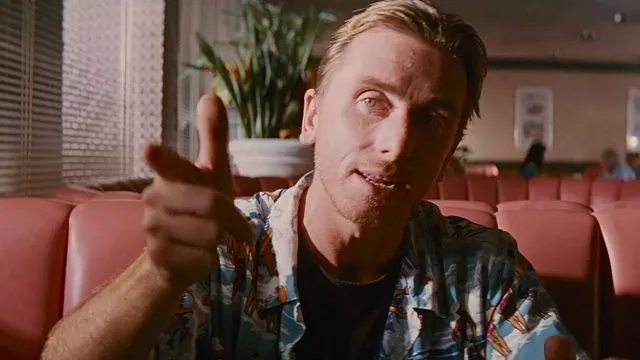Can you tell me more about the character this man is portraying in this image? The man in the image is portraying a character known for his complex, layered personality. He's shown in a casual setting, which contrasts with the intense, often dramatic nature of his role in the story. This juxtaposition adds depth to his character, inviting viewers to ponder his thoughts and feelings in this seemingly relaxed moment. 